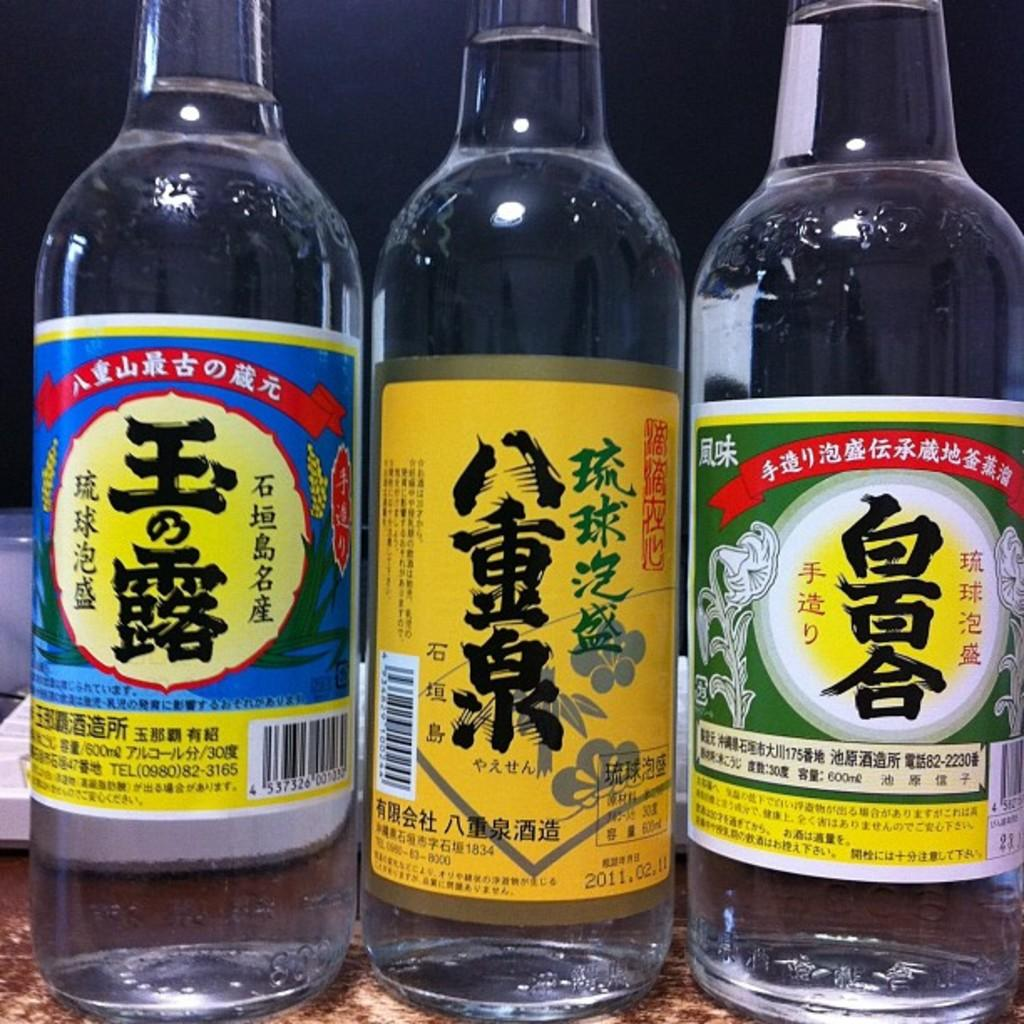<image>
Create a compact narrative representing the image presented. 3 bottles of alcohol with asian lettering on labels, one has phone number of  (0980)82-3165 